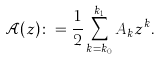Convert formula to latex. <formula><loc_0><loc_0><loc_500><loc_500>\mathcal { A } ( z ) \colon = \frac { 1 } { 2 } \sum _ { k = k _ { 0 } } ^ { k _ { 1 } } A _ { k } z ^ { k } .</formula> 